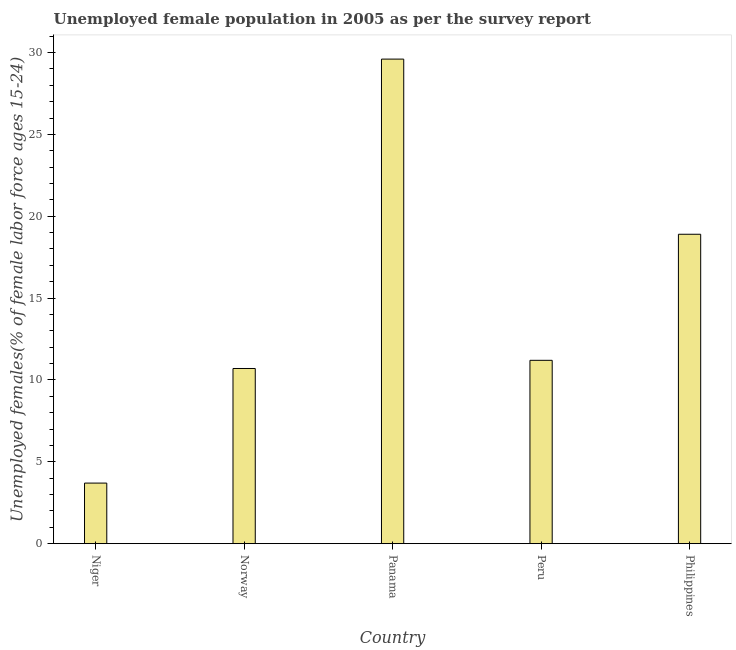What is the title of the graph?
Ensure brevity in your answer.  Unemployed female population in 2005 as per the survey report. What is the label or title of the Y-axis?
Keep it short and to the point. Unemployed females(% of female labor force ages 15-24). What is the unemployed female youth in Niger?
Keep it short and to the point. 3.7. Across all countries, what is the maximum unemployed female youth?
Offer a very short reply. 29.6. Across all countries, what is the minimum unemployed female youth?
Keep it short and to the point. 3.7. In which country was the unemployed female youth maximum?
Your answer should be very brief. Panama. In which country was the unemployed female youth minimum?
Make the answer very short. Niger. What is the sum of the unemployed female youth?
Your answer should be compact. 74.1. What is the difference between the unemployed female youth in Norway and Panama?
Offer a very short reply. -18.9. What is the average unemployed female youth per country?
Offer a very short reply. 14.82. What is the median unemployed female youth?
Your answer should be very brief. 11.2. In how many countries, is the unemployed female youth greater than 6 %?
Give a very brief answer. 4. What is the ratio of the unemployed female youth in Peru to that in Philippines?
Offer a very short reply. 0.59. What is the difference between the highest and the second highest unemployed female youth?
Provide a short and direct response. 10.7. Is the sum of the unemployed female youth in Norway and Philippines greater than the maximum unemployed female youth across all countries?
Offer a very short reply. No. What is the difference between the highest and the lowest unemployed female youth?
Keep it short and to the point. 25.9. In how many countries, is the unemployed female youth greater than the average unemployed female youth taken over all countries?
Give a very brief answer. 2. How many bars are there?
Keep it short and to the point. 5. What is the difference between two consecutive major ticks on the Y-axis?
Keep it short and to the point. 5. What is the Unemployed females(% of female labor force ages 15-24) in Niger?
Your answer should be compact. 3.7. What is the Unemployed females(% of female labor force ages 15-24) of Norway?
Make the answer very short. 10.7. What is the Unemployed females(% of female labor force ages 15-24) in Panama?
Offer a terse response. 29.6. What is the Unemployed females(% of female labor force ages 15-24) of Peru?
Keep it short and to the point. 11.2. What is the Unemployed females(% of female labor force ages 15-24) of Philippines?
Your answer should be compact. 18.9. What is the difference between the Unemployed females(% of female labor force ages 15-24) in Niger and Panama?
Your response must be concise. -25.9. What is the difference between the Unemployed females(% of female labor force ages 15-24) in Niger and Philippines?
Provide a short and direct response. -15.2. What is the difference between the Unemployed females(% of female labor force ages 15-24) in Norway and Panama?
Your response must be concise. -18.9. What is the difference between the Unemployed females(% of female labor force ages 15-24) in Norway and Peru?
Keep it short and to the point. -0.5. What is the difference between the Unemployed females(% of female labor force ages 15-24) in Panama and Peru?
Give a very brief answer. 18.4. What is the ratio of the Unemployed females(% of female labor force ages 15-24) in Niger to that in Norway?
Your answer should be compact. 0.35. What is the ratio of the Unemployed females(% of female labor force ages 15-24) in Niger to that in Panama?
Give a very brief answer. 0.12. What is the ratio of the Unemployed females(% of female labor force ages 15-24) in Niger to that in Peru?
Ensure brevity in your answer.  0.33. What is the ratio of the Unemployed females(% of female labor force ages 15-24) in Niger to that in Philippines?
Your answer should be very brief. 0.2. What is the ratio of the Unemployed females(% of female labor force ages 15-24) in Norway to that in Panama?
Offer a very short reply. 0.36. What is the ratio of the Unemployed females(% of female labor force ages 15-24) in Norway to that in Peru?
Give a very brief answer. 0.95. What is the ratio of the Unemployed females(% of female labor force ages 15-24) in Norway to that in Philippines?
Give a very brief answer. 0.57. What is the ratio of the Unemployed females(% of female labor force ages 15-24) in Panama to that in Peru?
Give a very brief answer. 2.64. What is the ratio of the Unemployed females(% of female labor force ages 15-24) in Panama to that in Philippines?
Your response must be concise. 1.57. What is the ratio of the Unemployed females(% of female labor force ages 15-24) in Peru to that in Philippines?
Provide a succinct answer. 0.59. 